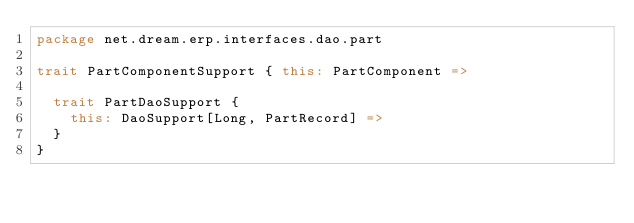<code> <loc_0><loc_0><loc_500><loc_500><_Scala_>package net.dream.erp.interfaces.dao.part

trait PartComponentSupport { this: PartComponent =>

  trait PartDaoSupport {
    this: DaoSupport[Long, PartRecord] =>
  }
}
</code> 